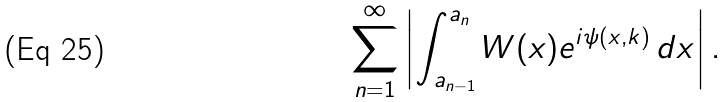Convert formula to latex. <formula><loc_0><loc_0><loc_500><loc_500>\sum _ { n = 1 } ^ { \infty } \left | \int _ { a _ { n - 1 } } ^ { a _ { n } } W ( x ) e ^ { i \psi ( x , k ) } \, d x \right | .</formula> 